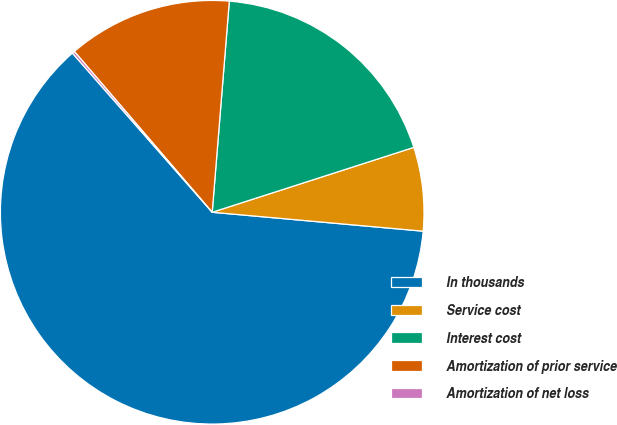<chart> <loc_0><loc_0><loc_500><loc_500><pie_chart><fcel>In thousands<fcel>Service cost<fcel>Interest cost<fcel>Amortization of prior service<fcel>Amortization of net loss<nl><fcel>62.11%<fcel>6.38%<fcel>18.76%<fcel>12.57%<fcel>0.19%<nl></chart> 